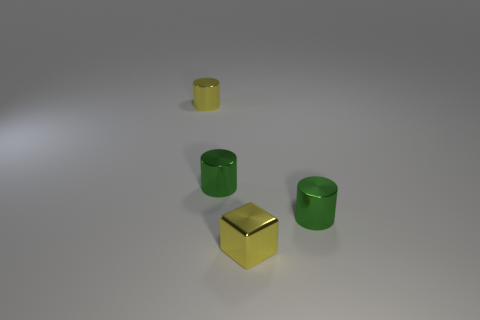Add 4 small yellow metal cylinders. How many objects exist? 8 Subtract all blocks. How many objects are left? 3 Add 4 green things. How many green things are left? 6 Add 3 brown cylinders. How many brown cylinders exist? 3 Subtract 1 yellow cylinders. How many objects are left? 3 Subtract all tiny cylinders. Subtract all small yellow shiny blocks. How many objects are left? 0 